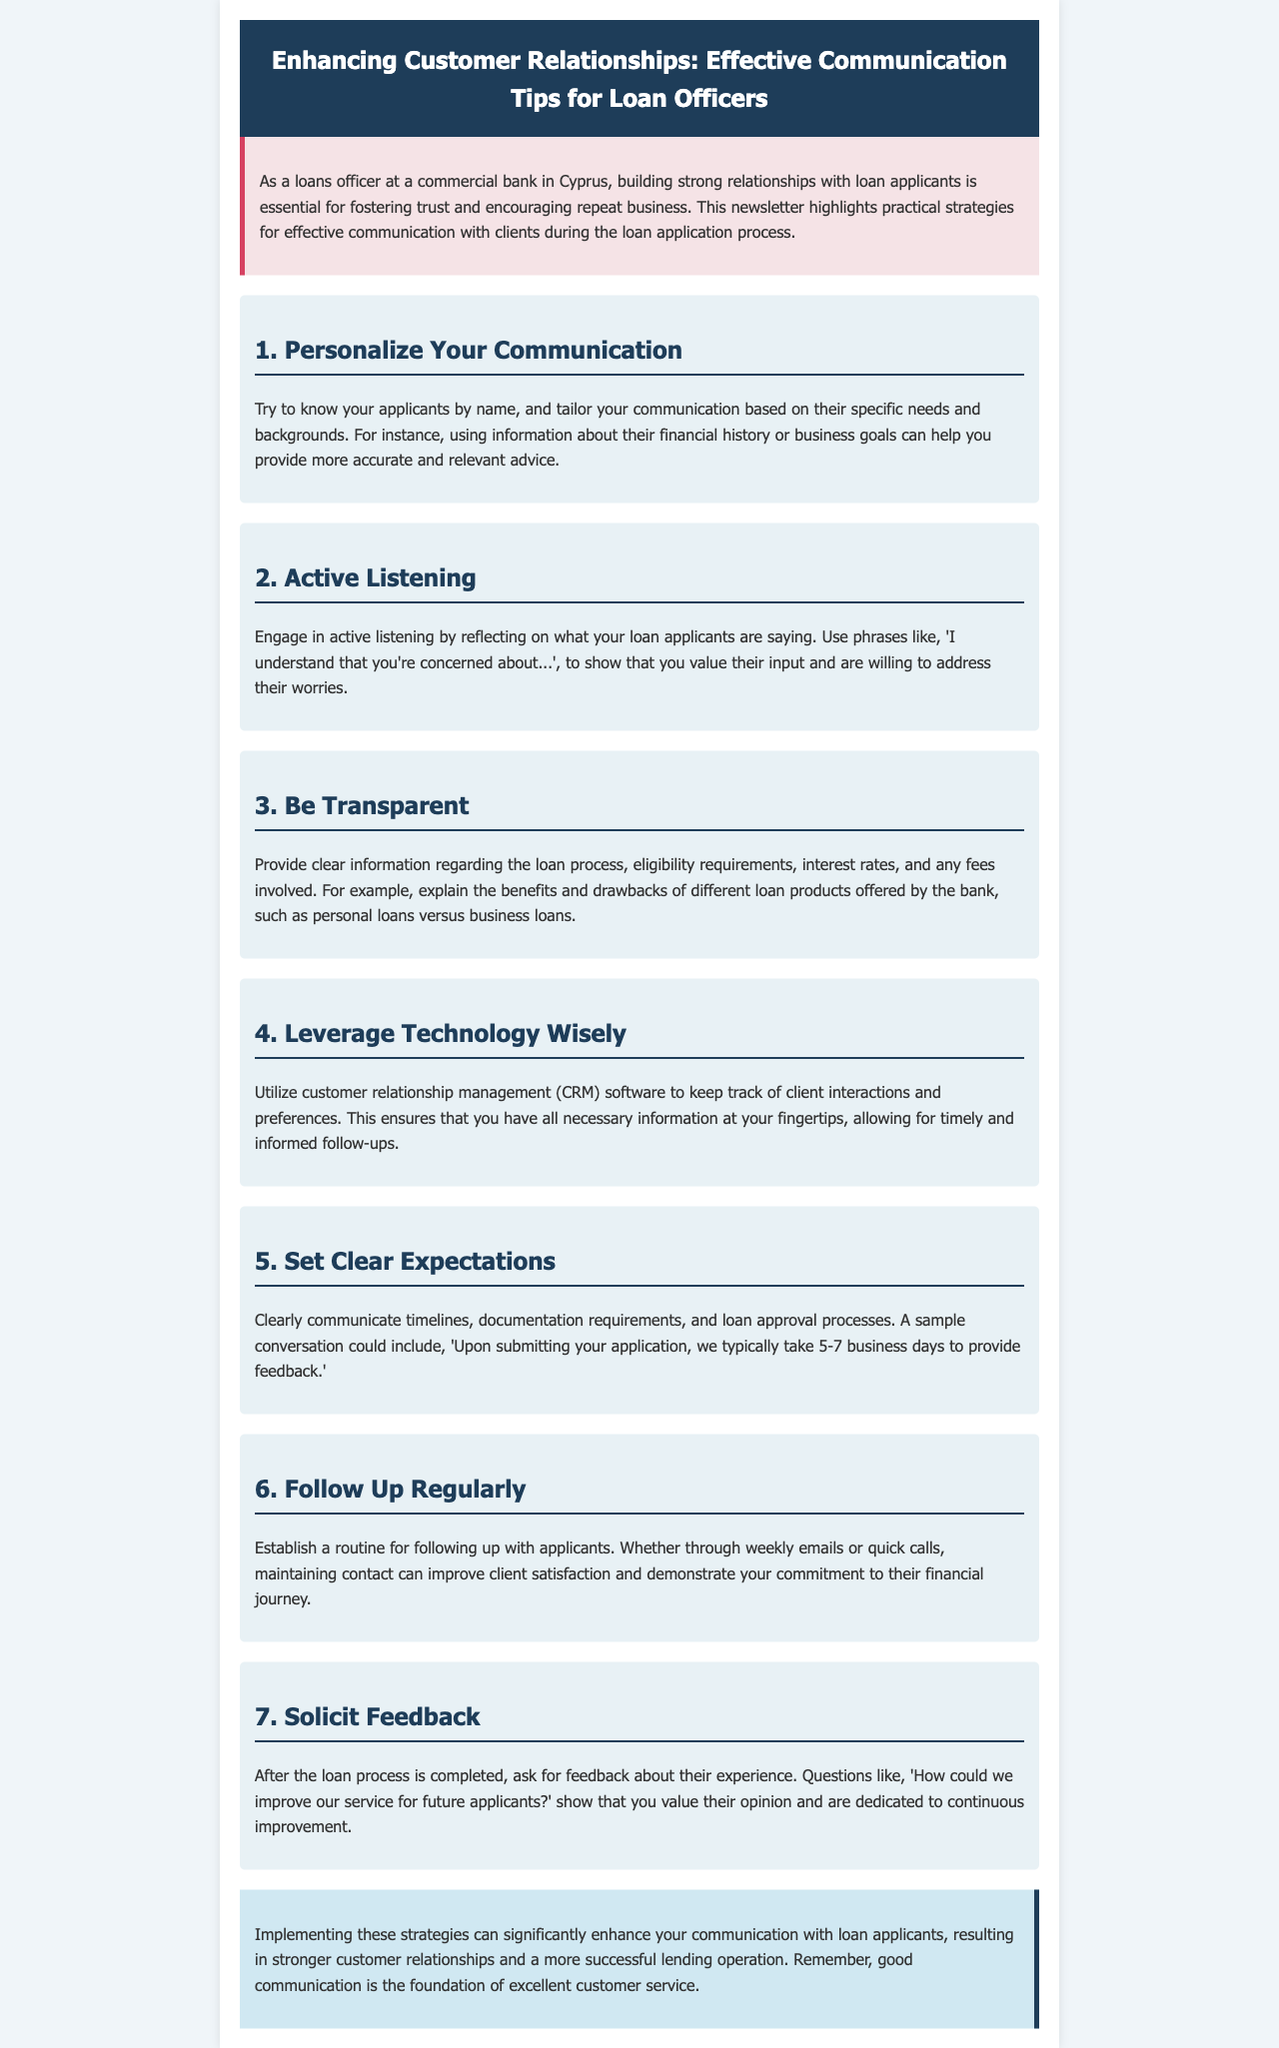what is the title of the newsletter? The title of the newsletter is clearly stated at the top of the document within the header section.
Answer: Enhancing Customer Relationships: Effective Communication Tips for Loan Officers how many strategies for effective communication are mentioned? The number of strategies can be found by counting the numbered sections in the document.
Answer: 7 what is one key aspect of active listening mentioned? The key aspect of active listening is detailed within the specific section discussing this strategy.
Answer: reflecting on what your loan applicants are saying what phrase can be used to show understanding of an applicant's concerns? A direct quote from the document illustrates how to convey understanding in communication with applicants.
Answer: I understand that you're concerned about.. what should loan officers communicate clearly about? The document emphasizes the importance of transparent communication regarding specific topics in the loan process.
Answer: loan process what is a suggested method for following up with loan applicants? The document provides a suggestion regarding how to maintain communication with applicants after initial contact.
Answer: weekly emails or quick calls what feedback question is recommended to ask after loan processing? The specific feedback question provided in the document invites applicants to express their opinions on the service.
Answer: How could we improve our service for future applicants? 